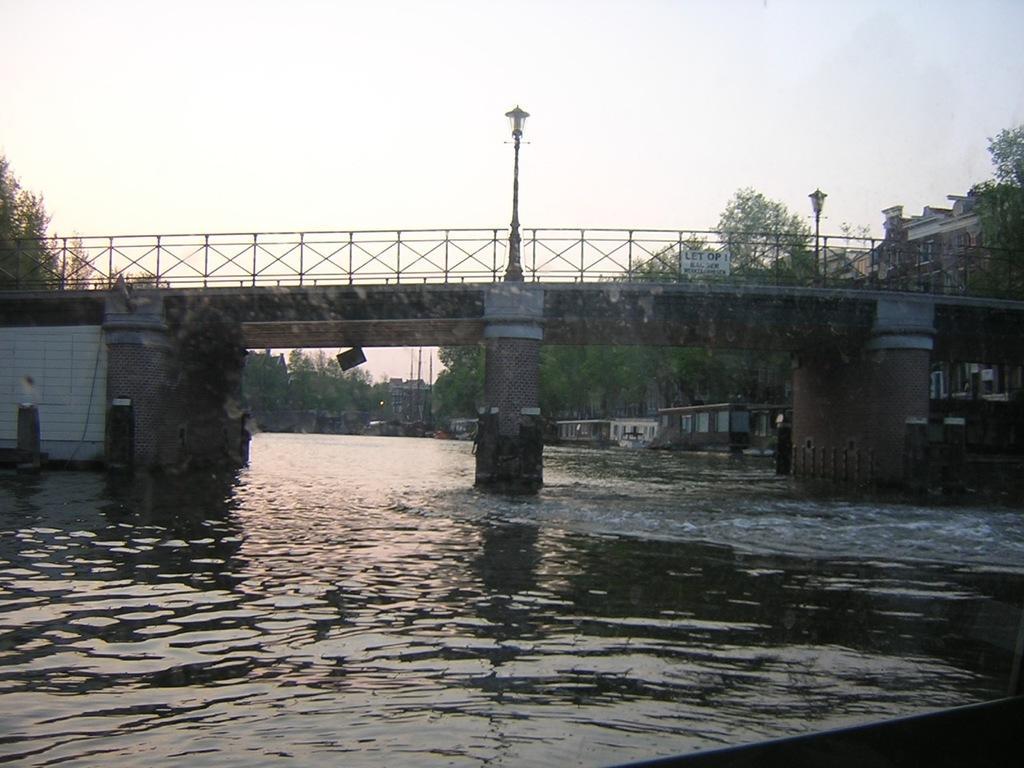In one or two sentences, can you explain what this image depicts? In this image there is a river with bridge on top beside the bridge there are buildings and trees. 